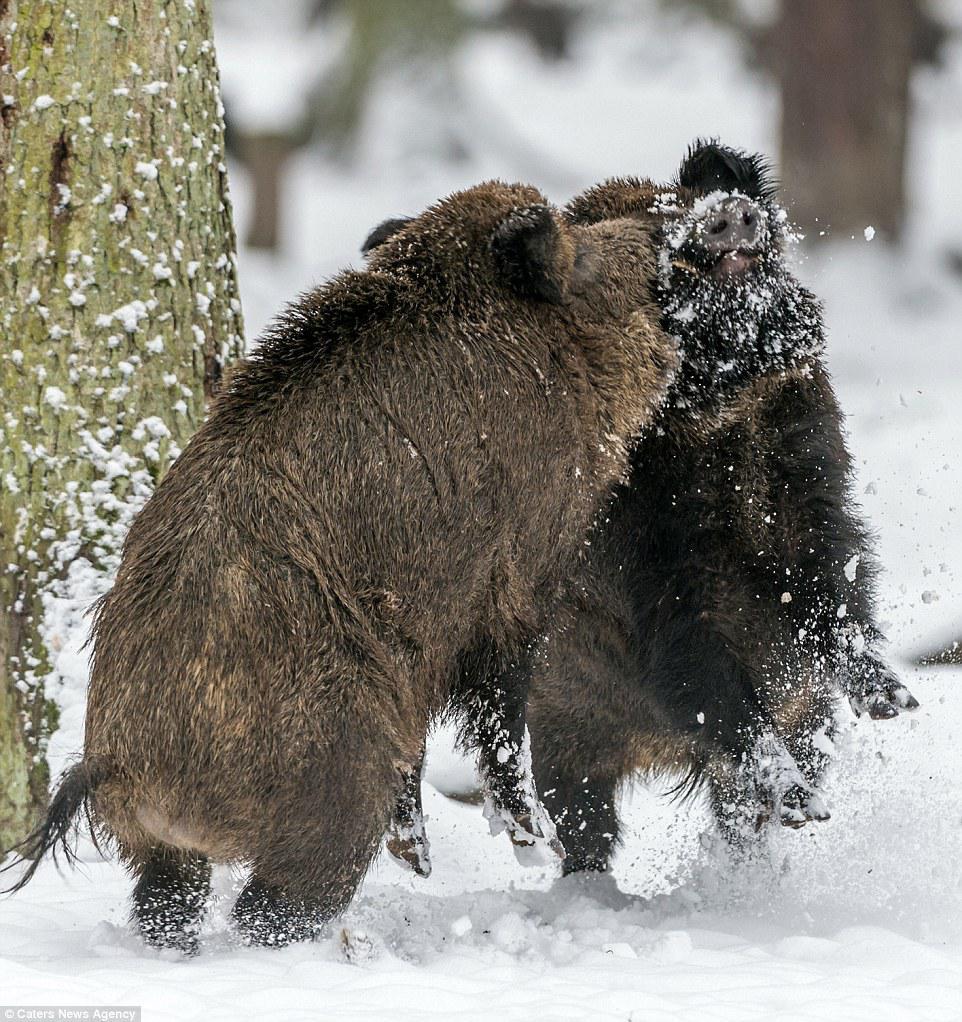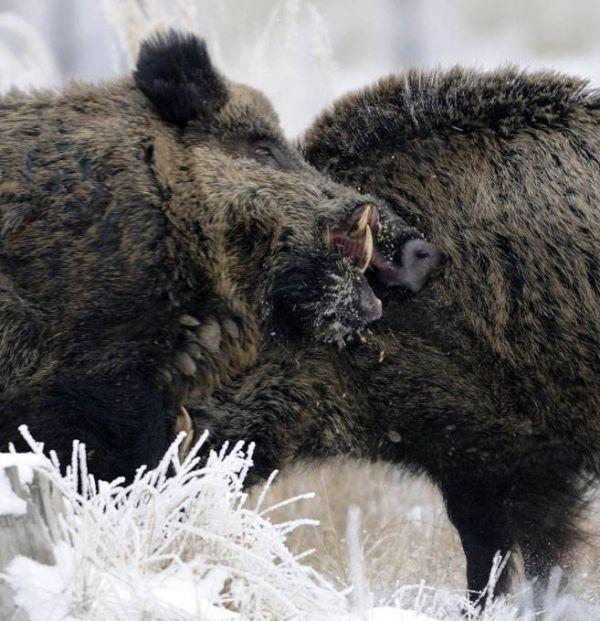The first image is the image on the left, the second image is the image on the right. Given the left and right images, does the statement "Each image shows two hogs in a face-to-face confrontation, and in one image the hogs have their front feet off the ground." hold true? Answer yes or no. Yes. The first image is the image on the left, the second image is the image on the right. Assess this claim about the two images: "The left and right image contains the same number of fighting hogs.". Correct or not? Answer yes or no. Yes. 